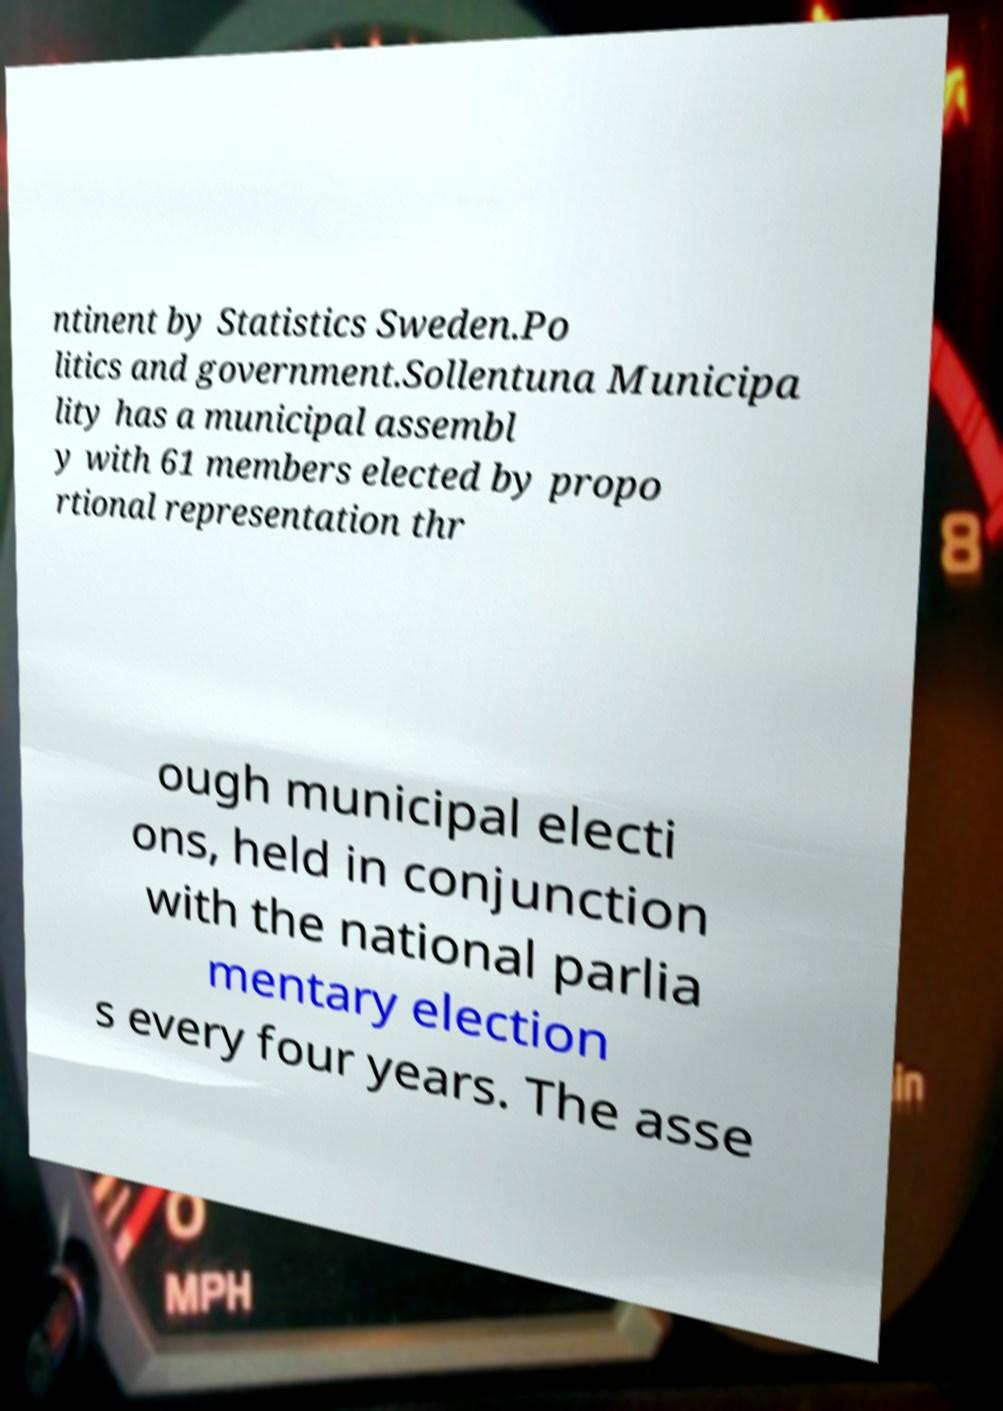Please identify and transcribe the text found in this image. ntinent by Statistics Sweden.Po litics and government.Sollentuna Municipa lity has a municipal assembl y with 61 members elected by propo rtional representation thr ough municipal electi ons, held in conjunction with the national parlia mentary election s every four years. The asse 